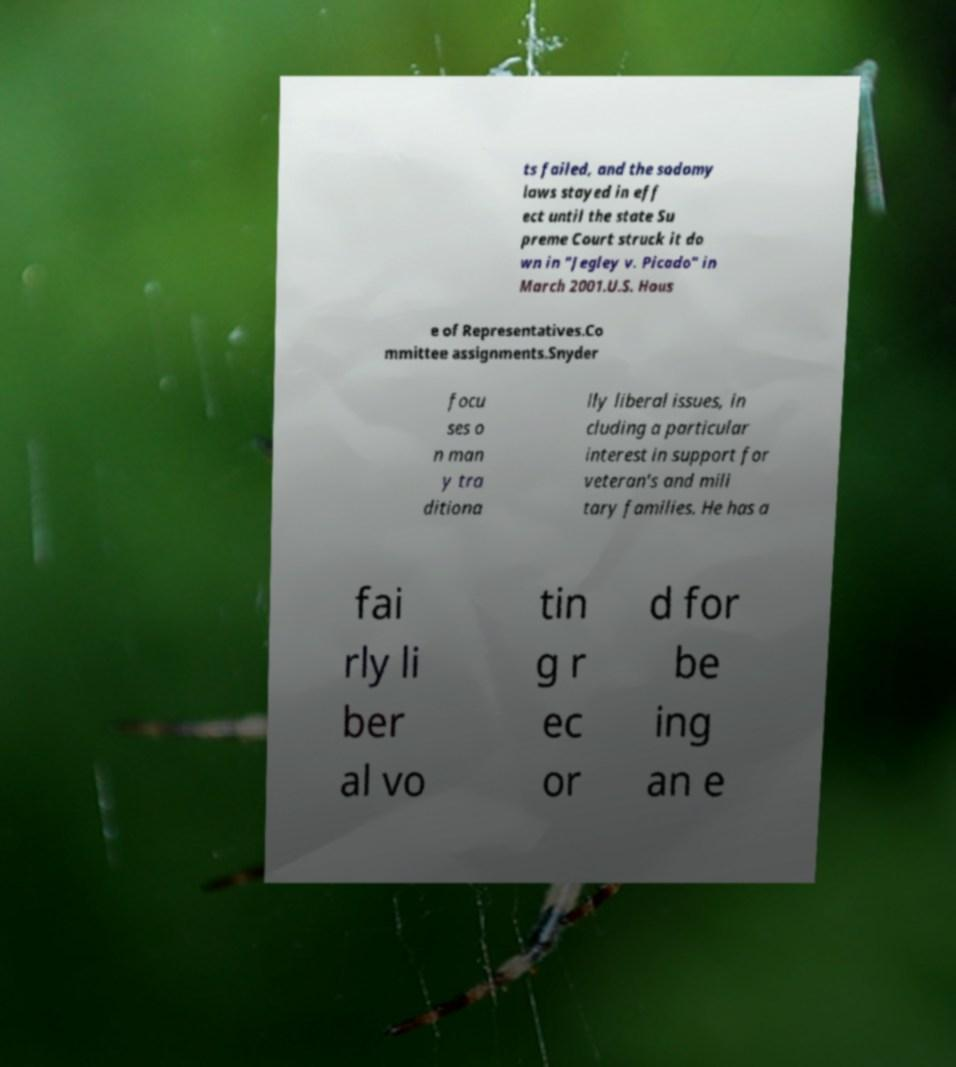For documentation purposes, I need the text within this image transcribed. Could you provide that? ts failed, and the sodomy laws stayed in eff ect until the state Su preme Court struck it do wn in "Jegley v. Picado" in March 2001.U.S. Hous e of Representatives.Co mmittee assignments.Snyder focu ses o n man y tra ditiona lly liberal issues, in cluding a particular interest in support for veteran's and mili tary families. He has a fai rly li ber al vo tin g r ec or d for be ing an e 